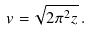Convert formula to latex. <formula><loc_0><loc_0><loc_500><loc_500>v = \sqrt { 2 \pi ^ { 2 } z } \, .</formula> 